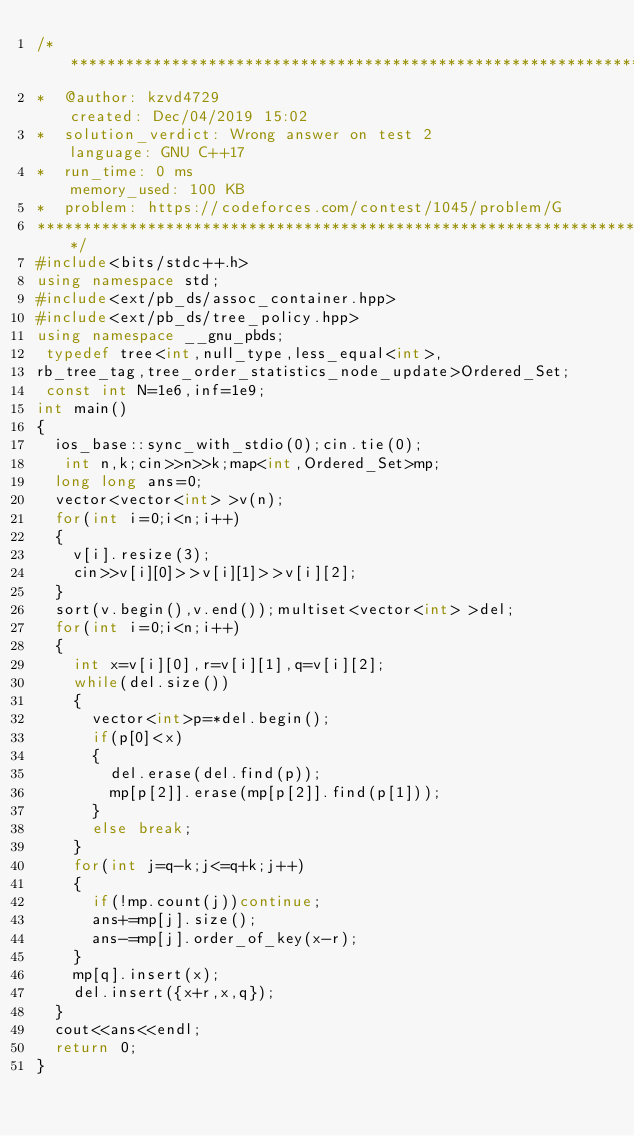Convert code to text. <code><loc_0><loc_0><loc_500><loc_500><_C++_>/****************************************************************************************
*  @author: kzvd4729                                         created: Dec/04/2019 15:02                        
*  solution_verdict: Wrong answer on test 2                  language: GNU C++17                               
*  run_time: 0 ms                                            memory_used: 100 KB                               
*  problem: https://codeforces.com/contest/1045/problem/G
****************************************************************************************/
#include<bits/stdc++.h>
using namespace std;
#include<ext/pb_ds/assoc_container.hpp>
#include<ext/pb_ds/tree_policy.hpp>
using namespace __gnu_pbds;
 typedef tree<int,null_type,less_equal<int>,
rb_tree_tag,tree_order_statistics_node_update>Ordered_Set;
 const int N=1e6,inf=1e9;
int main()
{
  ios_base::sync_with_stdio(0);cin.tie(0);
   int n,k;cin>>n>>k;map<int,Ordered_Set>mp;
  long long ans=0;
  vector<vector<int> >v(n);
  for(int i=0;i<n;i++)
  {
    v[i].resize(3);
    cin>>v[i][0]>>v[i][1]>>v[i][2];
  }
  sort(v.begin(),v.end());multiset<vector<int> >del;
  for(int i=0;i<n;i++)
  {
    int x=v[i][0],r=v[i][1],q=v[i][2];
    while(del.size())
    {
      vector<int>p=*del.begin();
      if(p[0]<x)
      {
        del.erase(del.find(p));
        mp[p[2]].erase(mp[p[2]].find(p[1]));
      }
      else break;
    }
    for(int j=q-k;j<=q+k;j++)
    {
      if(!mp.count(j))continue;
      ans+=mp[j].size();
      ans-=mp[j].order_of_key(x-r);
    }
    mp[q].insert(x);
    del.insert({x+r,x,q});
  }
  cout<<ans<<endl;
  return 0;
}</code> 